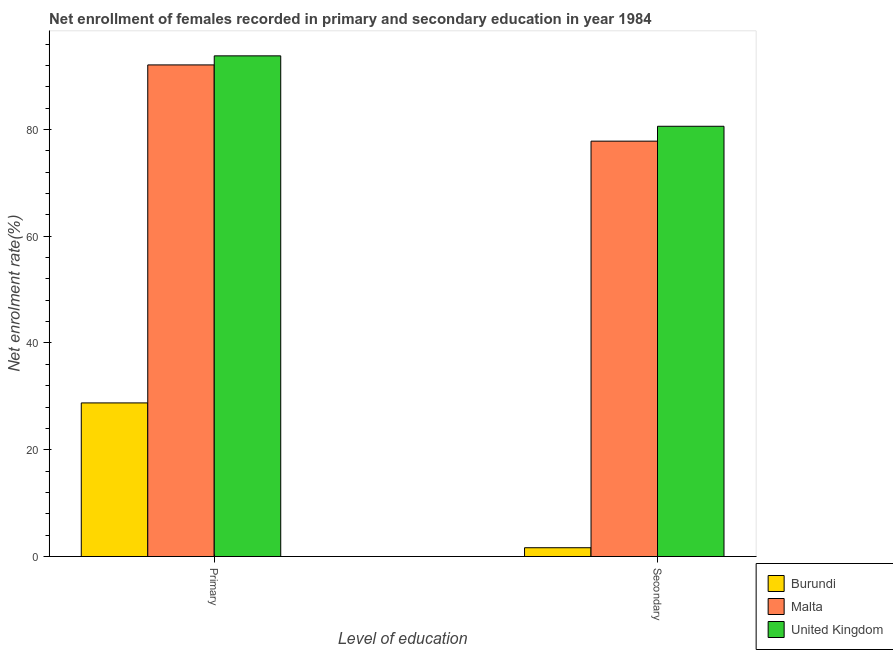How many groups of bars are there?
Your response must be concise. 2. Are the number of bars per tick equal to the number of legend labels?
Keep it short and to the point. Yes. How many bars are there on the 1st tick from the right?
Your answer should be compact. 3. What is the label of the 1st group of bars from the left?
Your answer should be very brief. Primary. What is the enrollment rate in secondary education in Malta?
Your answer should be compact. 77.81. Across all countries, what is the maximum enrollment rate in primary education?
Keep it short and to the point. 93.79. Across all countries, what is the minimum enrollment rate in secondary education?
Keep it short and to the point. 1.65. In which country was the enrollment rate in primary education maximum?
Give a very brief answer. United Kingdom. In which country was the enrollment rate in primary education minimum?
Give a very brief answer. Burundi. What is the total enrollment rate in primary education in the graph?
Offer a very short reply. 214.65. What is the difference between the enrollment rate in secondary education in Burundi and that in Malta?
Provide a short and direct response. -76.16. What is the difference between the enrollment rate in secondary education in Burundi and the enrollment rate in primary education in Malta?
Provide a succinct answer. -90.44. What is the average enrollment rate in secondary education per country?
Provide a short and direct response. 53.35. What is the difference between the enrollment rate in primary education and enrollment rate in secondary education in Burundi?
Provide a short and direct response. 27.13. In how many countries, is the enrollment rate in secondary education greater than 60 %?
Ensure brevity in your answer.  2. What is the ratio of the enrollment rate in secondary education in Burundi to that in United Kingdom?
Keep it short and to the point. 0.02. Is the enrollment rate in secondary education in United Kingdom less than that in Burundi?
Keep it short and to the point. No. In how many countries, is the enrollment rate in secondary education greater than the average enrollment rate in secondary education taken over all countries?
Make the answer very short. 2. What does the 1st bar from the left in Primary represents?
Offer a very short reply. Burundi. What does the 2nd bar from the right in Primary represents?
Keep it short and to the point. Malta. How many bars are there?
Offer a very short reply. 6. Are all the bars in the graph horizontal?
Make the answer very short. No. How many countries are there in the graph?
Your response must be concise. 3. Does the graph contain any zero values?
Offer a very short reply. No. Does the graph contain grids?
Provide a succinct answer. No. Where does the legend appear in the graph?
Keep it short and to the point. Bottom right. How many legend labels are there?
Your response must be concise. 3. What is the title of the graph?
Your response must be concise. Net enrollment of females recorded in primary and secondary education in year 1984. What is the label or title of the X-axis?
Provide a succinct answer. Level of education. What is the label or title of the Y-axis?
Give a very brief answer. Net enrolment rate(%). What is the Net enrolment rate(%) in Burundi in Primary?
Keep it short and to the point. 28.77. What is the Net enrolment rate(%) of Malta in Primary?
Offer a terse response. 92.09. What is the Net enrolment rate(%) in United Kingdom in Primary?
Offer a terse response. 93.79. What is the Net enrolment rate(%) in Burundi in Secondary?
Your response must be concise. 1.65. What is the Net enrolment rate(%) of Malta in Secondary?
Offer a very short reply. 77.81. What is the Net enrolment rate(%) in United Kingdom in Secondary?
Provide a succinct answer. 80.6. Across all Level of education, what is the maximum Net enrolment rate(%) of Burundi?
Give a very brief answer. 28.77. Across all Level of education, what is the maximum Net enrolment rate(%) of Malta?
Offer a very short reply. 92.09. Across all Level of education, what is the maximum Net enrolment rate(%) of United Kingdom?
Keep it short and to the point. 93.79. Across all Level of education, what is the minimum Net enrolment rate(%) of Burundi?
Provide a short and direct response. 1.65. Across all Level of education, what is the minimum Net enrolment rate(%) of Malta?
Offer a very short reply. 77.81. Across all Level of education, what is the minimum Net enrolment rate(%) of United Kingdom?
Your response must be concise. 80.6. What is the total Net enrolment rate(%) in Burundi in the graph?
Make the answer very short. 30.42. What is the total Net enrolment rate(%) of Malta in the graph?
Give a very brief answer. 169.9. What is the total Net enrolment rate(%) of United Kingdom in the graph?
Your answer should be very brief. 174.38. What is the difference between the Net enrolment rate(%) of Burundi in Primary and that in Secondary?
Provide a short and direct response. 27.13. What is the difference between the Net enrolment rate(%) in Malta in Primary and that in Secondary?
Ensure brevity in your answer.  14.28. What is the difference between the Net enrolment rate(%) in United Kingdom in Primary and that in Secondary?
Keep it short and to the point. 13.19. What is the difference between the Net enrolment rate(%) of Burundi in Primary and the Net enrolment rate(%) of Malta in Secondary?
Make the answer very short. -49.04. What is the difference between the Net enrolment rate(%) of Burundi in Primary and the Net enrolment rate(%) of United Kingdom in Secondary?
Offer a very short reply. -51.82. What is the difference between the Net enrolment rate(%) of Malta in Primary and the Net enrolment rate(%) of United Kingdom in Secondary?
Ensure brevity in your answer.  11.5. What is the average Net enrolment rate(%) of Burundi per Level of education?
Your answer should be compact. 15.21. What is the average Net enrolment rate(%) of Malta per Level of education?
Provide a short and direct response. 84.95. What is the average Net enrolment rate(%) in United Kingdom per Level of education?
Offer a very short reply. 87.19. What is the difference between the Net enrolment rate(%) of Burundi and Net enrolment rate(%) of Malta in Primary?
Offer a terse response. -63.32. What is the difference between the Net enrolment rate(%) in Burundi and Net enrolment rate(%) in United Kingdom in Primary?
Offer a very short reply. -65.01. What is the difference between the Net enrolment rate(%) of Malta and Net enrolment rate(%) of United Kingdom in Primary?
Ensure brevity in your answer.  -1.7. What is the difference between the Net enrolment rate(%) in Burundi and Net enrolment rate(%) in Malta in Secondary?
Keep it short and to the point. -76.16. What is the difference between the Net enrolment rate(%) of Burundi and Net enrolment rate(%) of United Kingdom in Secondary?
Keep it short and to the point. -78.95. What is the difference between the Net enrolment rate(%) of Malta and Net enrolment rate(%) of United Kingdom in Secondary?
Offer a very short reply. -2.78. What is the ratio of the Net enrolment rate(%) in Burundi in Primary to that in Secondary?
Make the answer very short. 17.46. What is the ratio of the Net enrolment rate(%) of Malta in Primary to that in Secondary?
Ensure brevity in your answer.  1.18. What is the ratio of the Net enrolment rate(%) in United Kingdom in Primary to that in Secondary?
Your answer should be very brief. 1.16. What is the difference between the highest and the second highest Net enrolment rate(%) in Burundi?
Keep it short and to the point. 27.13. What is the difference between the highest and the second highest Net enrolment rate(%) in Malta?
Make the answer very short. 14.28. What is the difference between the highest and the second highest Net enrolment rate(%) in United Kingdom?
Provide a succinct answer. 13.19. What is the difference between the highest and the lowest Net enrolment rate(%) in Burundi?
Keep it short and to the point. 27.13. What is the difference between the highest and the lowest Net enrolment rate(%) in Malta?
Your response must be concise. 14.28. What is the difference between the highest and the lowest Net enrolment rate(%) of United Kingdom?
Provide a succinct answer. 13.19. 